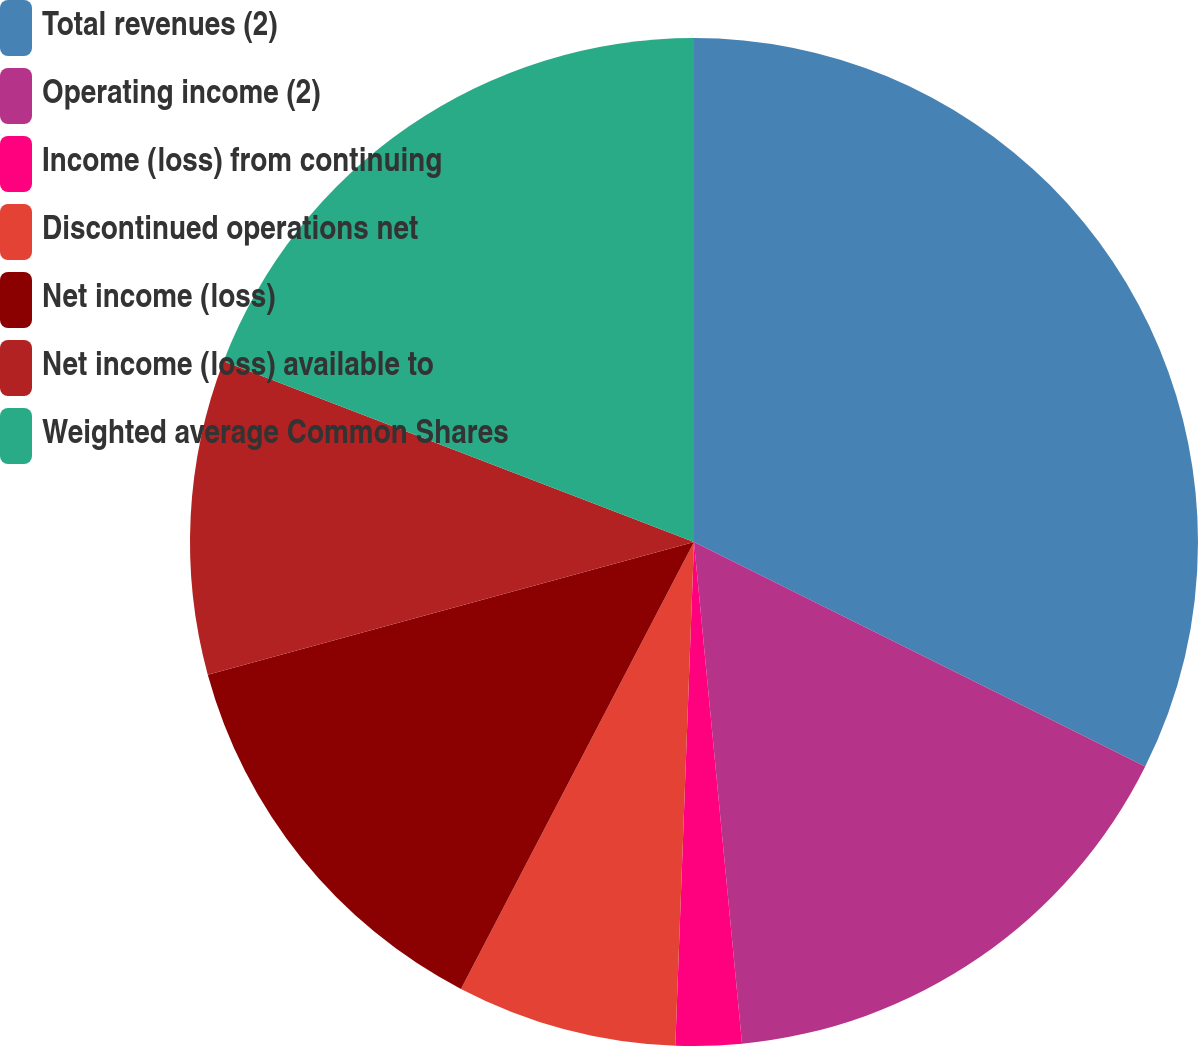Convert chart to OTSL. <chart><loc_0><loc_0><loc_500><loc_500><pie_chart><fcel>Total revenues (2)<fcel>Operating income (2)<fcel>Income (loss) from continuing<fcel>Discontinued operations net<fcel>Net income (loss)<fcel>Net income (loss) available to<fcel>Weighted average Common Shares<nl><fcel>32.35%<fcel>16.13%<fcel>2.11%<fcel>7.06%<fcel>13.11%<fcel>10.08%<fcel>19.16%<nl></chart> 